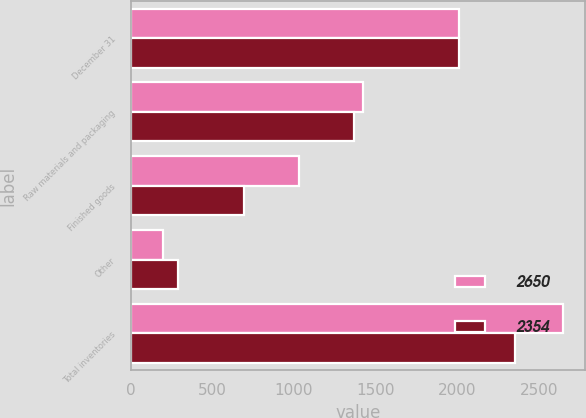Convert chart to OTSL. <chart><loc_0><loc_0><loc_500><loc_500><stacked_bar_chart><ecel><fcel>December 31<fcel>Raw materials and packaging<fcel>Finished goods<fcel>Other<fcel>Total inventories<nl><fcel>2650<fcel>2010<fcel>1425<fcel>1029<fcel>196<fcel>2650<nl><fcel>2354<fcel>2009<fcel>1366<fcel>697<fcel>291<fcel>2354<nl></chart> 